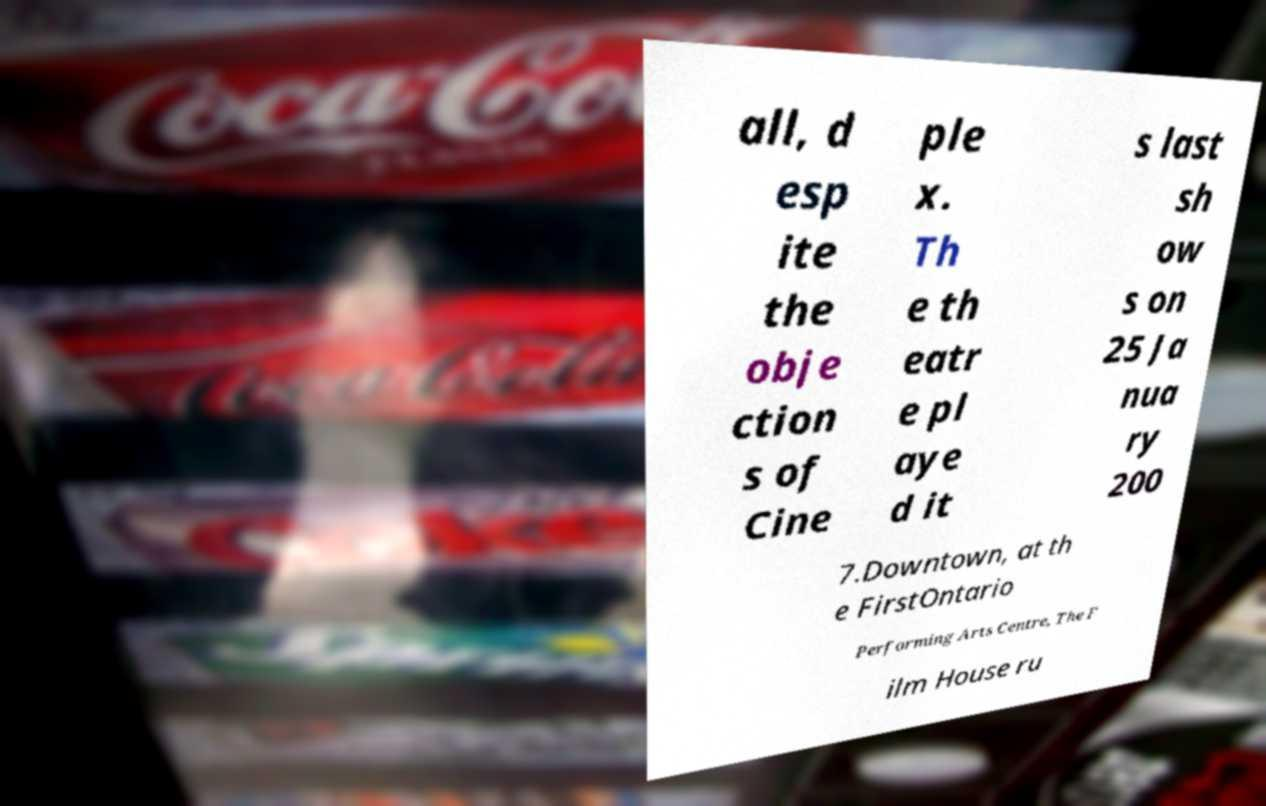What messages or text are displayed in this image? I need them in a readable, typed format. all, d esp ite the obje ction s of Cine ple x. Th e th eatr e pl aye d it s last sh ow s on 25 Ja nua ry 200 7.Downtown, at th e FirstOntario Performing Arts Centre, The F ilm House ru 